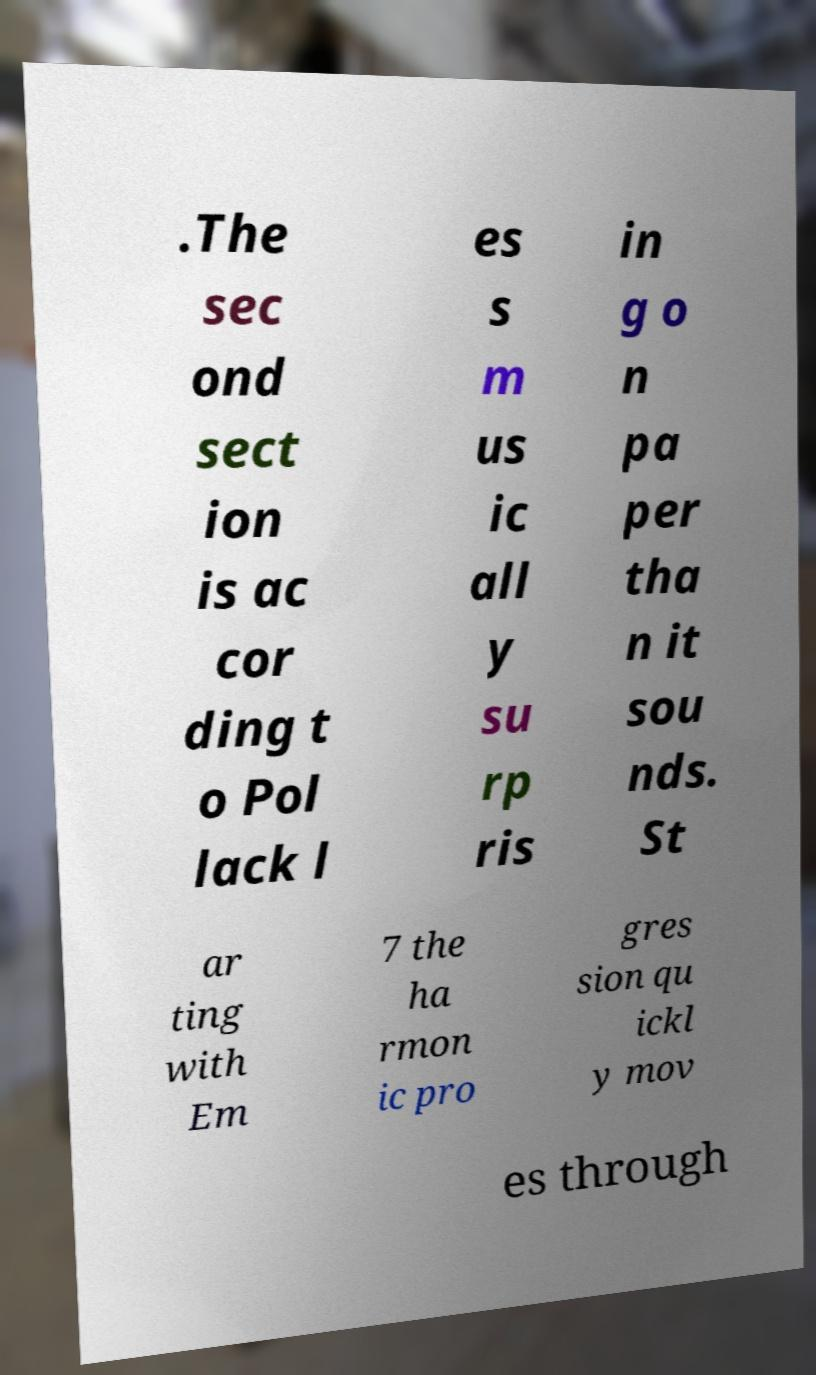For documentation purposes, I need the text within this image transcribed. Could you provide that? .The sec ond sect ion is ac cor ding t o Pol lack l es s m us ic all y su rp ris in g o n pa per tha n it sou nds. St ar ting with Em 7 the ha rmon ic pro gres sion qu ickl y mov es through 